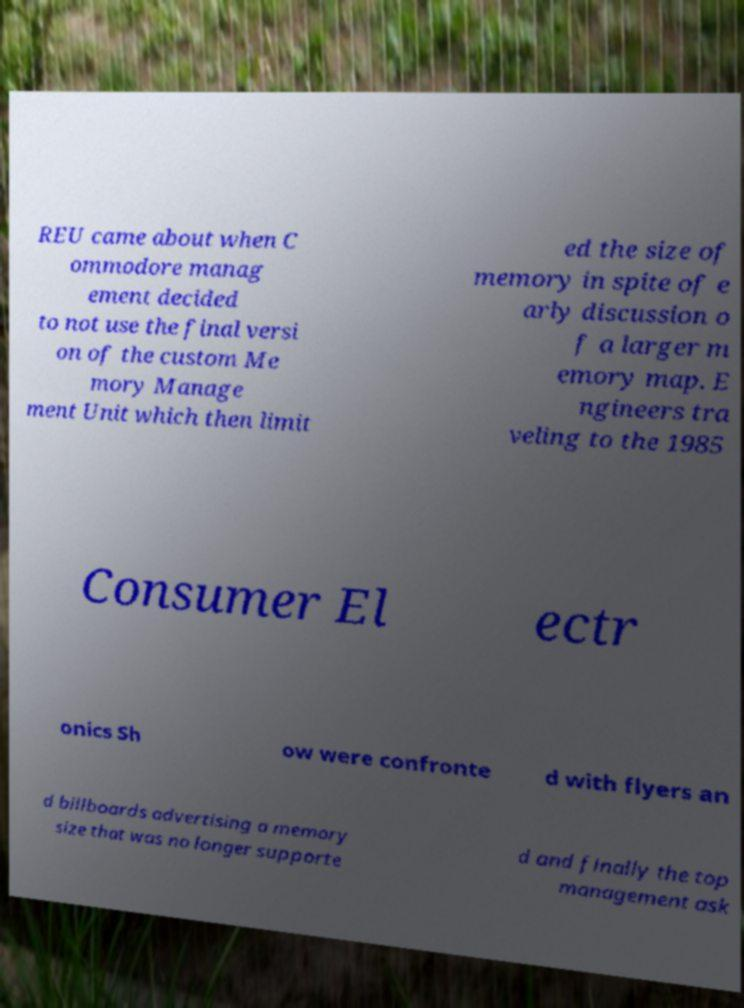Could you assist in decoding the text presented in this image and type it out clearly? REU came about when C ommodore manag ement decided to not use the final versi on of the custom Me mory Manage ment Unit which then limit ed the size of memory in spite of e arly discussion o f a larger m emory map. E ngineers tra veling to the 1985 Consumer El ectr onics Sh ow were confronte d with flyers an d billboards advertising a memory size that was no longer supporte d and finally the top management ask 